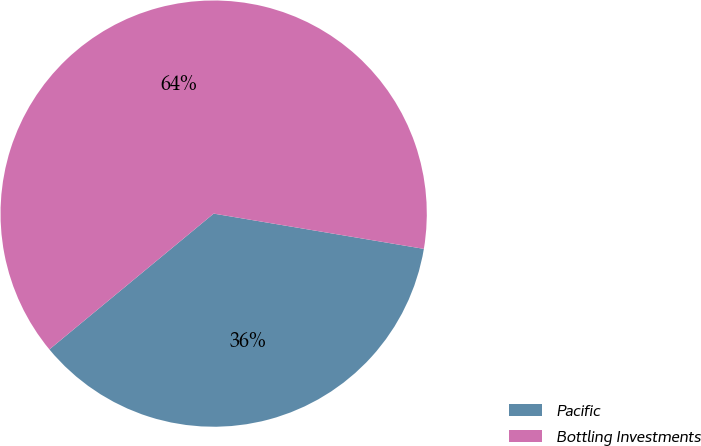Convert chart to OTSL. <chart><loc_0><loc_0><loc_500><loc_500><pie_chart><fcel>Pacific<fcel>Bottling Investments<nl><fcel>36.36%<fcel>63.64%<nl></chart> 